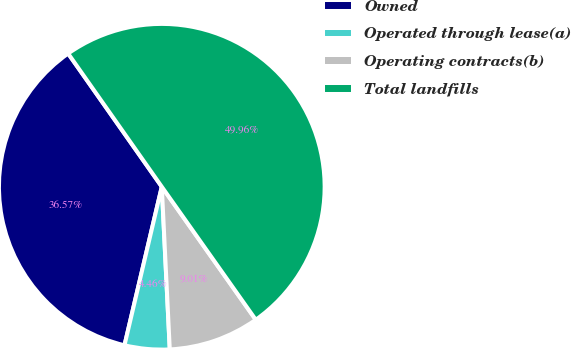Convert chart. <chart><loc_0><loc_0><loc_500><loc_500><pie_chart><fcel>Owned<fcel>Operated through lease(a)<fcel>Operating contracts(b)<fcel>Total landfills<nl><fcel>36.57%<fcel>4.46%<fcel>9.01%<fcel>49.96%<nl></chart> 